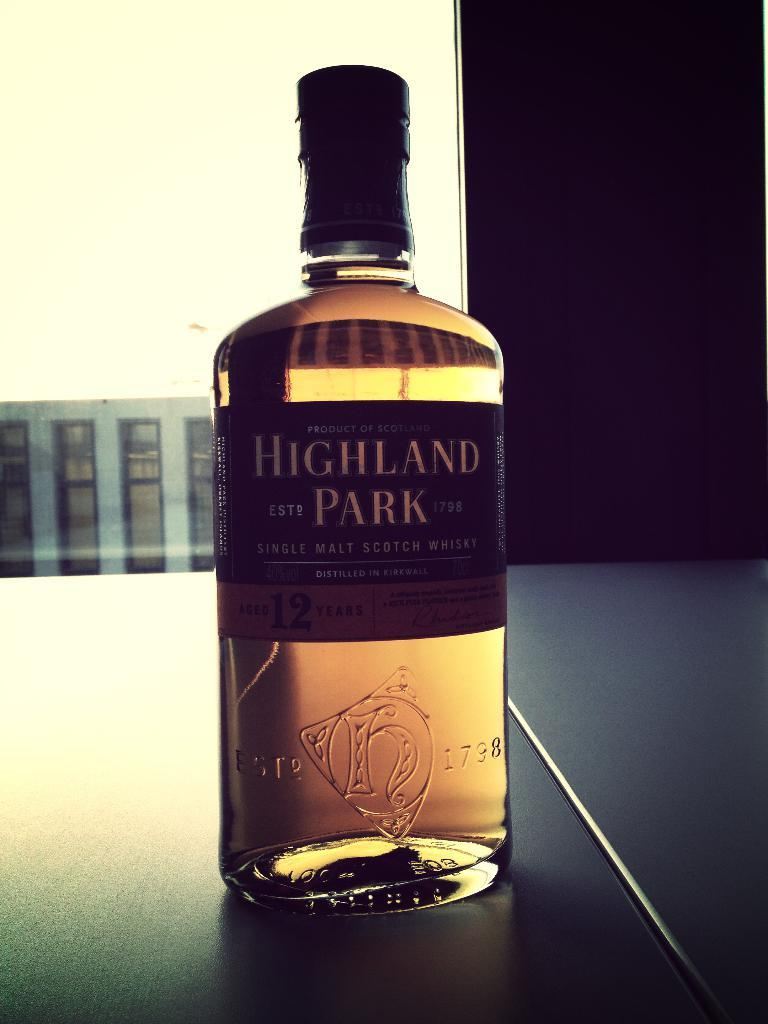What object can be seen in the image? There is a bottle in the image. Can you see a rabbit eating lunch with a toad in the image? No, there is no rabbit, lunch, or toad present in the image; only a bottle is visible. 